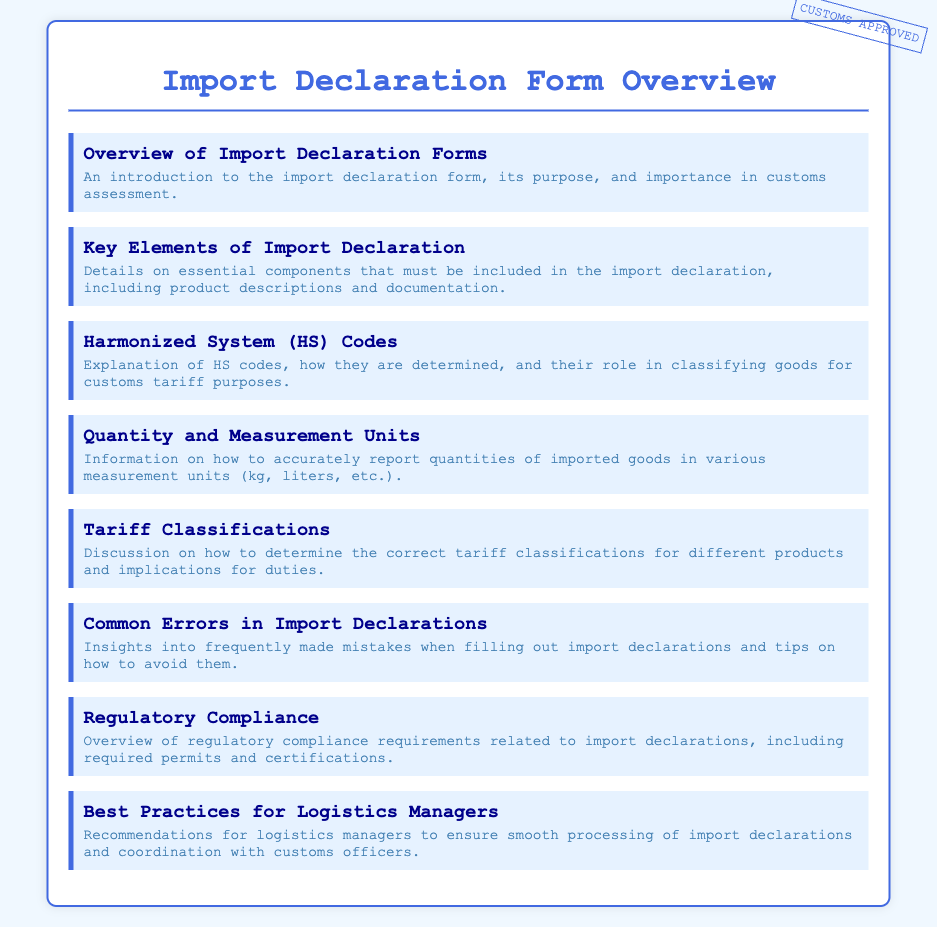What is the purpose of the import declaration form? The purpose is detailed in the document as an introduction to its importance in customs assessment.
Answer: Customs assessment What color is the border of the container? The border color can be found in the style section of the document which specifies its color.
Answer: #4169e1 How many key elements of import declaration are mentioned? The section mentions essential components that must be included in the import declaration.
Answer: 7 What does HS stand for in the context of this document? The document provides insight into the term used for classifying goods for customs tariff purposes.
Answer: Harmonized System What does the "CUSTOMS APPROVED" stamp indicate? The stamp signifies the status of the form in relation to customs processing.
Answer: Approved What common errors does the document mention? Insights into common mistakes when filling out import declarations are discussed in that section.
Answer: Common mistakes What is the significance of tariff classifications? The implications of determining correct classifications for duties is explained in this section.
Answer: Duties What is the main audience of the best practices section? The recommendations provided are directed towards ensuring smooth processing of import declarations.
Answer: Logistics managers How are quantities of imported goods reported? The information section gives details on accurate reporting methods for imported goods.
Answer: Various measurement units 